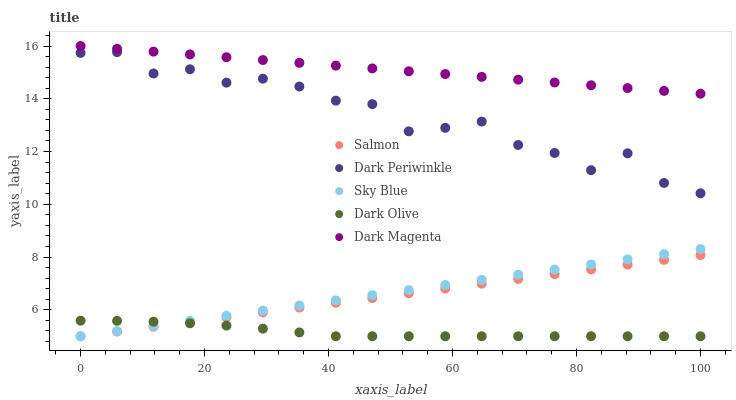Does Dark Olive have the minimum area under the curve?
Answer yes or no. Yes. Does Dark Magenta have the maximum area under the curve?
Answer yes or no. Yes. Does Salmon have the minimum area under the curve?
Answer yes or no. No. Does Salmon have the maximum area under the curve?
Answer yes or no. No. Is Sky Blue the smoothest?
Answer yes or no. Yes. Is Dark Periwinkle the roughest?
Answer yes or no. Yes. Is Dark Olive the smoothest?
Answer yes or no. No. Is Dark Olive the roughest?
Answer yes or no. No. Does Sky Blue have the lowest value?
Answer yes or no. Yes. Does Dark Periwinkle have the lowest value?
Answer yes or no. No. Does Dark Magenta have the highest value?
Answer yes or no. Yes. Does Salmon have the highest value?
Answer yes or no. No. Is Sky Blue less than Dark Periwinkle?
Answer yes or no. Yes. Is Dark Periwinkle greater than Dark Olive?
Answer yes or no. Yes. Does Salmon intersect Dark Olive?
Answer yes or no. Yes. Is Salmon less than Dark Olive?
Answer yes or no. No. Is Salmon greater than Dark Olive?
Answer yes or no. No. Does Sky Blue intersect Dark Periwinkle?
Answer yes or no. No. 